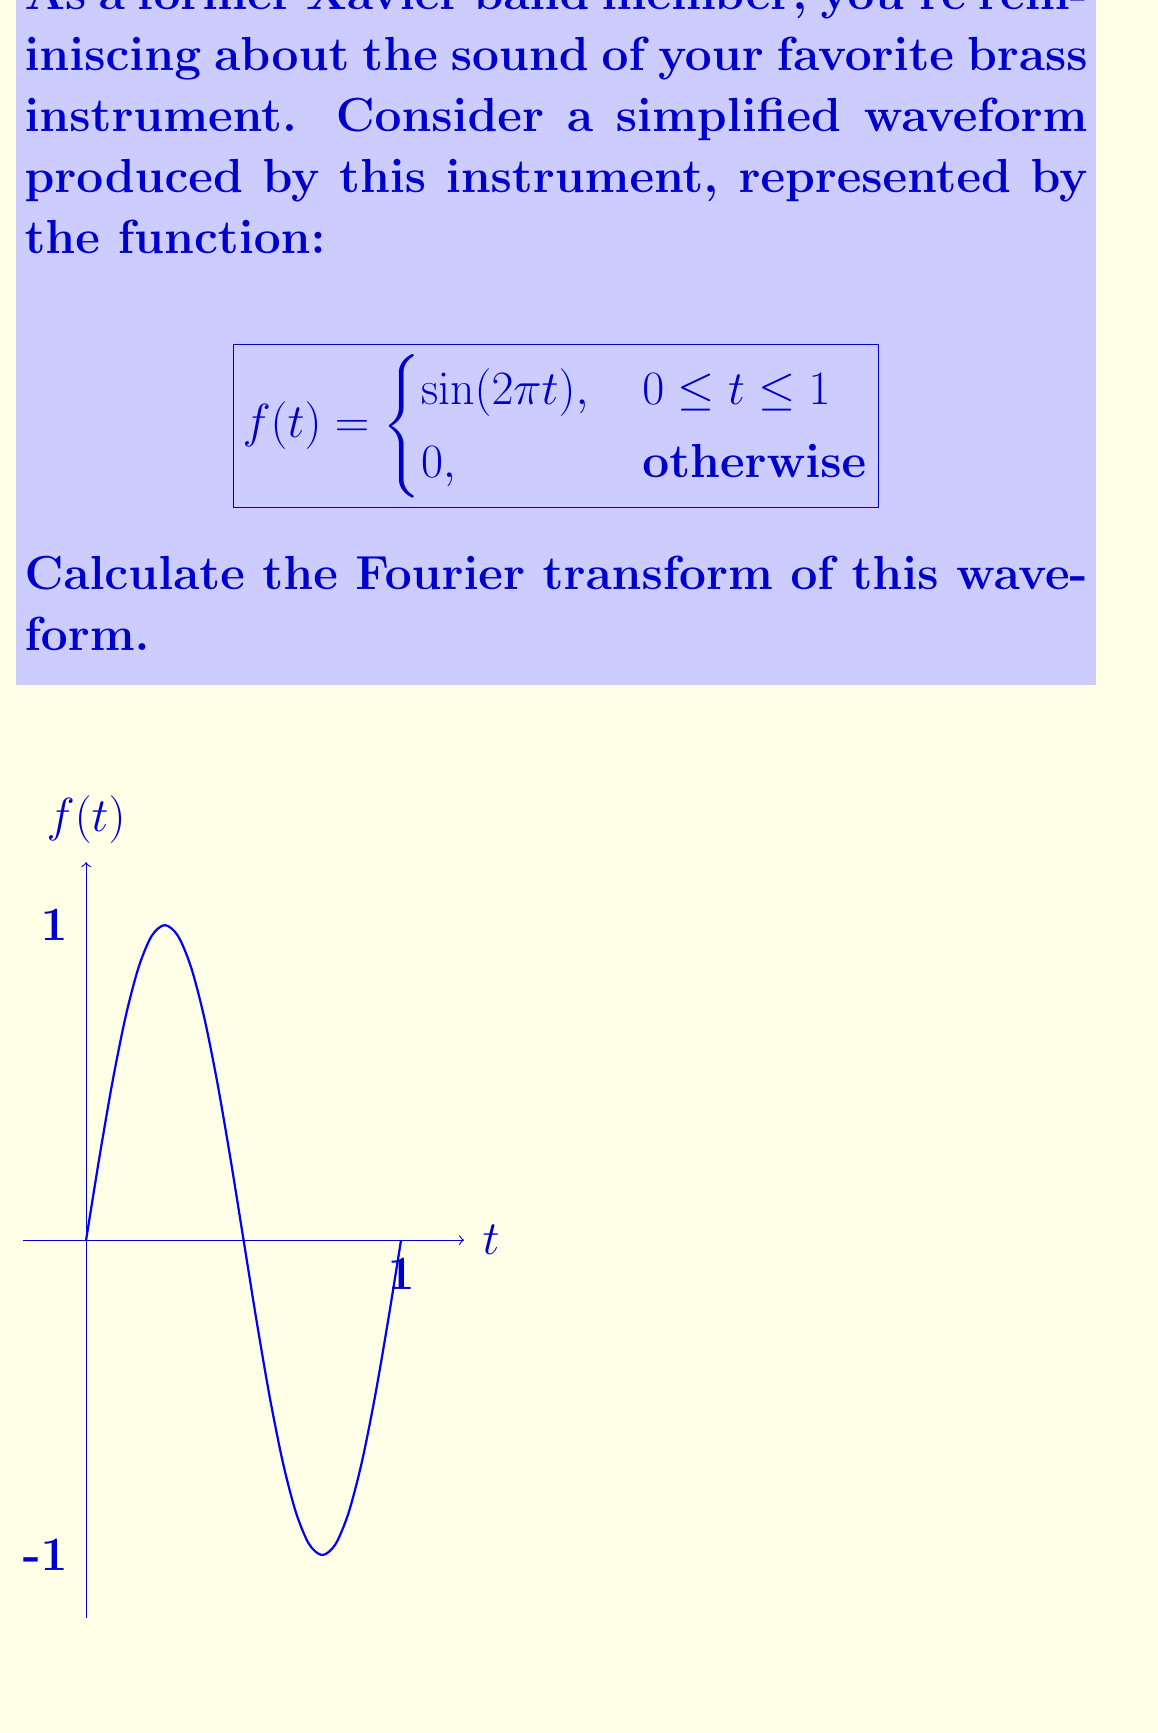Help me with this question. Let's approach this step-by-step:

1) The Fourier transform is defined as:

   $$F(\omega) = \int_{-\infty}^{\infty} f(t) e^{-i\omega t} dt$$

2) Given our function, we only need to integrate from 0 to 1:

   $$F(\omega) = \int_{0}^{1} \sin(2\pi t) e^{-i\omega t} dt$$

3) We can use Euler's formula to rewrite sin:

   $$\sin(2\pi t) = \frac{e^{i2\pi t} - e^{-i2\pi t}}{2i}$$

4) Substituting this in:

   $$F(\omega) = \frac{1}{2i} \int_{0}^{1} (e^{i2\pi t} - e^{-i2\pi t}) e^{-i\omega t} dt$$

5) Simplify:

   $$F(\omega) = \frac{1}{2i} \int_{0}^{1} (e^{i(2\pi-\omega)t} - e^{-i(2\pi+\omega)t}) dt$$

6) Integrate:

   $$F(\omega) = \frac{1}{2i} \left[\frac{e^{i(2\pi-\omega)t}}{i(2\pi-\omega)} - \frac{e^{-i(2\pi+\omega)t}}{-i(2\pi+\omega)}\right]_0^1$$

7) Evaluate the bounds:

   $$F(\omega) = \frac{1}{2i} \left(\frac{e^{i(2\pi-\omega)} - 1}{i(2\pi-\omega)} + \frac{e^{-i(2\pi+\omega)} - 1}{i(2\pi+\omega)}\right)$$

8) Simplify:

   $$F(\omega) = \frac{e^{i(2\pi-\omega)} - 1}{2(2\pi-\omega)} + \frac{e^{-i(2\pi+\omega)} - 1}{2(2\pi+\omega)}$$

This is the Fourier transform of the given waveform.
Answer: $$F(\omega) = \frac{e^{i(2\pi-\omega)} - 1}{2(2\pi-\omega)} + \frac{e^{-i(2\pi+\omega)} - 1}{2(2\pi+\omega)}$$ 